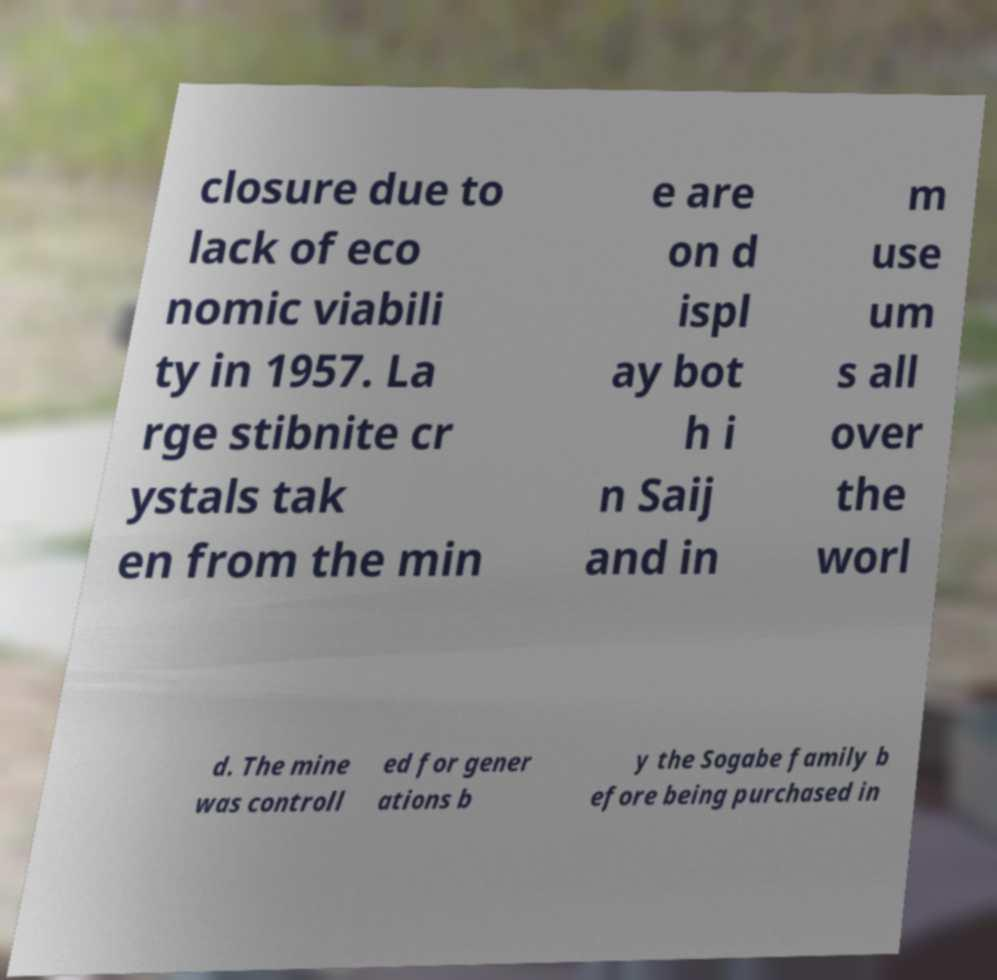Can you read and provide the text displayed in the image?This photo seems to have some interesting text. Can you extract and type it out for me? closure due to lack of eco nomic viabili ty in 1957. La rge stibnite cr ystals tak en from the min e are on d ispl ay bot h i n Saij and in m use um s all over the worl d. The mine was controll ed for gener ations b y the Sogabe family b efore being purchased in 